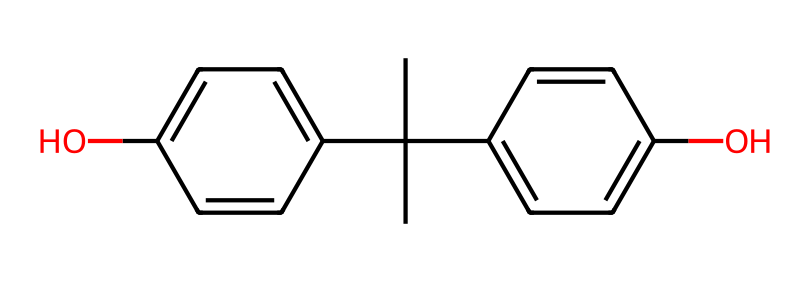What is the common name of this chemical? The chemical structure shown corresponds to bisphenol A, which is commonly referred to as BPA.
Answer: bisphenol A How many hydroxyl groups are present in this molecule? The structure has two hydroxyl (–OH) groups, indicated by the two oxygen atoms connected to hydrogen in the structure.
Answer: two What type of bonding is primarily present in this molecule? The predominant bonding in bisphenol A is covalent bonding, as it involves the sharing of electrons between atoms in the molecular structure.
Answer: covalent What is the total number of carbon atoms in the structure? By counting the 'C' atoms represented in the molecular structure, there are 15 carbon atoms in total.
Answer: 15 How many phenolic rings are in this compound? The chemical structure consists of two phenolic rings connected by a carbon chain, identifiable by the two benzene-like structures with hydroxyl groups.
Answer: two What property might this compound contribute to plastics? Bisphenol A can contribute to the toughness and heat resistance of plastics due to its structure being incorporated in polycarbonate production.
Answer: toughness Which feature of this molecule may influence its endocrine-disrupting potential? The presence of two hydroxyl groups in this molecule allows it to mimic estrogen in the body, which is linked to its endocrine-disrupting properties.
Answer: hydroxyl groups 